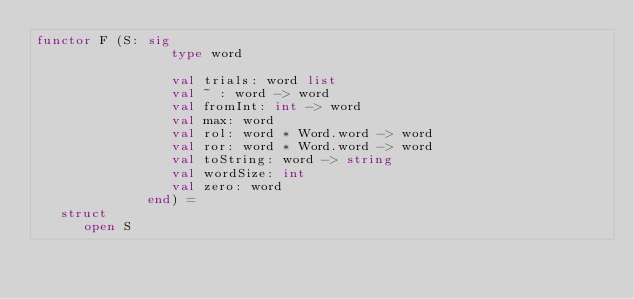<code> <loc_0><loc_0><loc_500><loc_500><_SML_>functor F (S: sig
                 type word

                 val trials: word list
                 val ~ : word -> word
                 val fromInt: int -> word
                 val max: word
                 val rol: word * Word.word -> word
                 val ror: word * Word.word -> word
                 val toString: word -> string
                 val wordSize: int
                 val zero: word
              end) =
   struct
      open S
</code> 